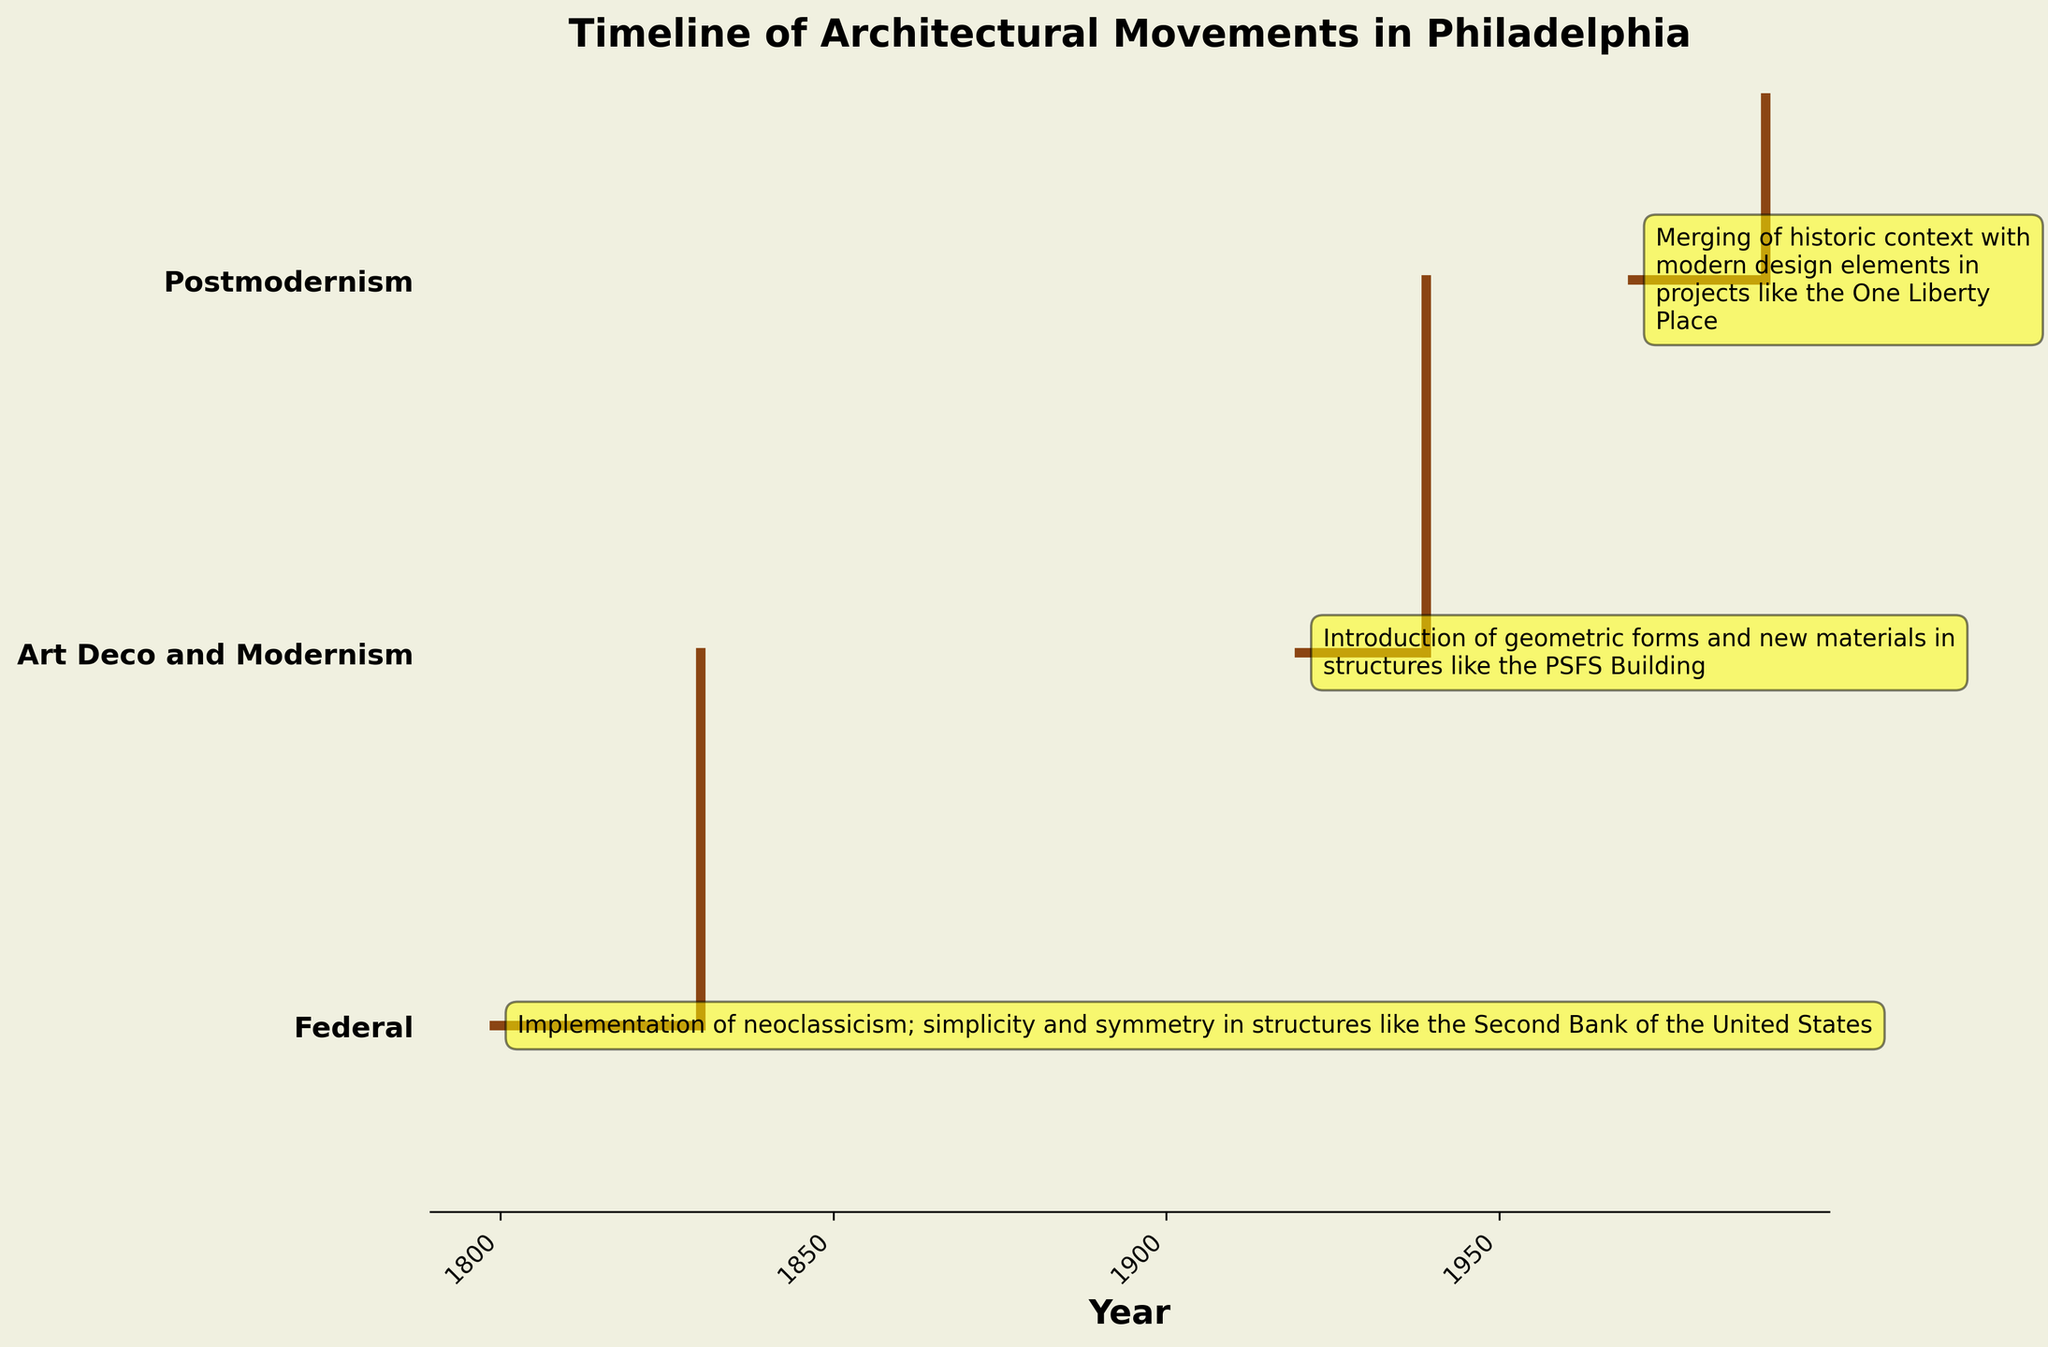When does the earliest architectural movement appear on the timeline? Look at the beginning of the timeline and identify the first era. The earliest era starts in 1799 with the Federal architectural movement.
Answer: 1799 Which architectural movement influenced geometric forms and new materials in Philadelphia? Read through the annotations for each architectural movement. The Art Deco and Modernism movement influenced geometric forms and new materials.
Answer: Art Deco and Modernism What is the duration of the Federal architectural era? Calculate the duration by subtracting the start year from the end year for the Federal era. The era is from 1799 to 1830, so the duration is 1830 - 1799 = 31 years.
Answer: 31 years How many architectural movements are represented in the plot? Count the number of different architectural movements listed on the Y-axis. There are three movements shown in the plot: Federal, Art Deco and Modernism, and Postmodernism.
Answer: 3 Which architectural movement lasted the longest? Compare the durations of each era by subtracting the start year from the end year for each movement and determine which has the longest duration. The Federal era lasted 31 years (1799-1830), Art Deco and Modernism lasted 19 years (1920-1939), and Postmodernism lasted 20 years (1970-1990). Therefore, the Federal era lasted the longest.
Answer: Federal Which architectural movement's era is closest to modern times? Identify the era that has the most recent end year. Postmodernism's era ended in 1990, which is the closest to modern times.
Answer: Postmodernism What architectural movement appears third on the Y-axis? Look at the Y-axis labels starting from the top and count to the third label. The third label is Postmodernism.
Answer: Postmodernism How does the Federal movement influence architectural design in Philadelphia? Read the annotation associated with the Federal movement for its influence. It emphasizes the implementation of neoclassicism with simplicity and symmetry in structures like the Second Bank of the United States.
Answer: Implementation of neoclassicism; simplicity and symmetry in structures like the Second Bank of the United States How many years after the Federal era did the Art Deco and Modernism movement begin? Calculate the number of years between the end of the Federal era (1830) and the start of the Art Deco and Modernism movement (1920). 1920 - 1830 = 90 years.
Answer: 90 years 